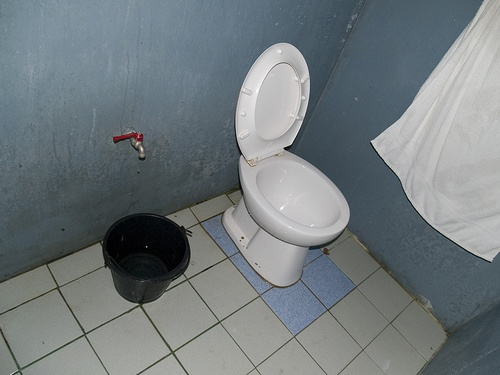Describe the objects in this image and their specific colors. I can see a toilet in gray, darkgray, and lightgray tones in this image. 